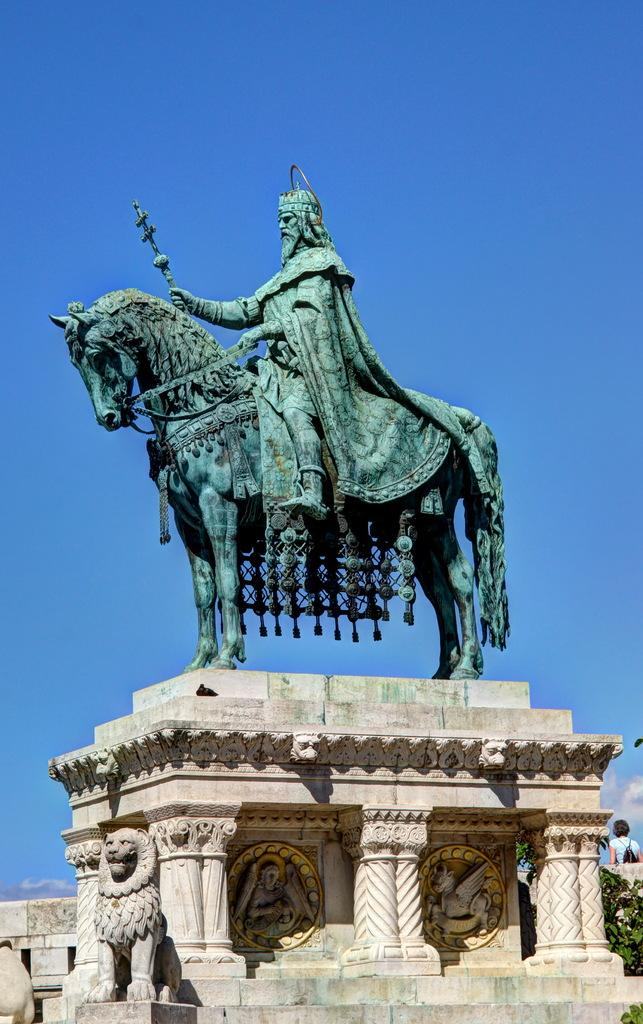What type of objects can be seen in the image? There are sculptures and pillars in the image. Can you describe one of the sculptures? There is a sculpture of a person sitting on a horse. What is the person in the image holding? There is a person with a bag in the image. What can be seen in the background of the image? The sky is visible in the background of the image. What type of hill can be seen in the image? There is no hill present in the image; it features sculptures, pillars, and a person with a bag. 